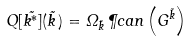Convert formula to latex. <formula><loc_0><loc_0><loc_500><loc_500>Q [ \vec { k ^ { * } } ] ( \vec { k } \, ) = \Omega _ { \vec { k } } \, \P c a n \left ( G ^ { \vec { k } } \right )</formula> 